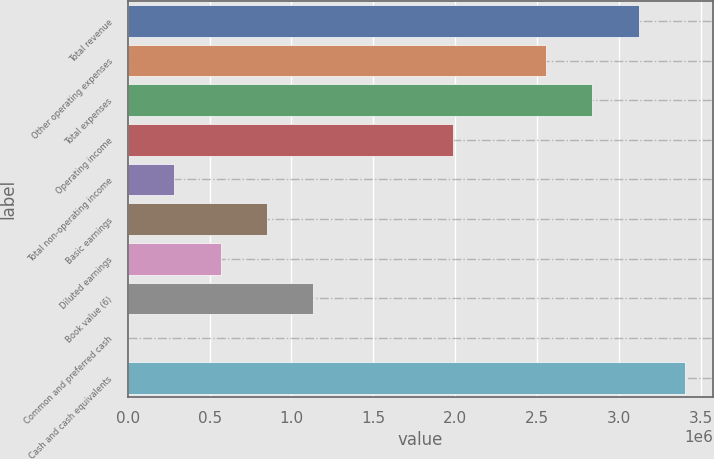Convert chart. <chart><loc_0><loc_0><loc_500><loc_500><bar_chart><fcel>Total revenue<fcel>Other operating expenses<fcel>Total expenses<fcel>Operating income<fcel>Total non-operating income<fcel>Basic earnings<fcel>Diluted earnings<fcel>Book value (6)<fcel>Common and preferred cash<fcel>Cash and cash equivalents<nl><fcel>3.11939e+06<fcel>2.55223e+06<fcel>2.83581e+06<fcel>1.98507e+06<fcel>283584<fcel>850746<fcel>567165<fcel>1.13433e+06<fcel>3.12<fcel>3.40297e+06<nl></chart> 